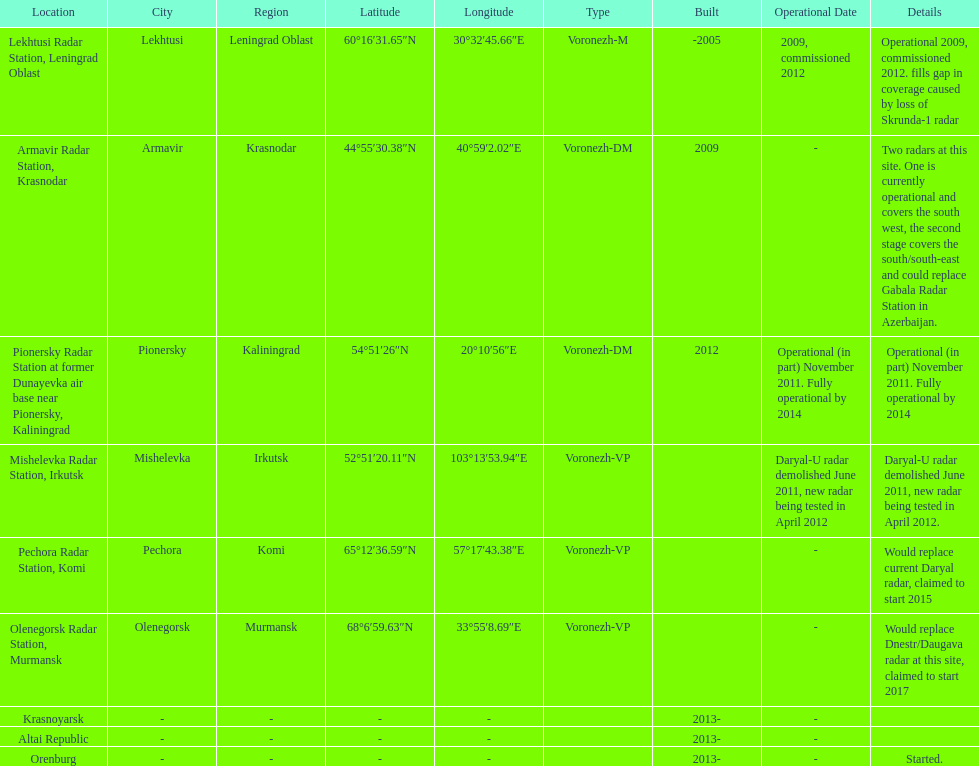How long did it take the pionersky radar station to go from partially operational to fully operational? 3 years. 